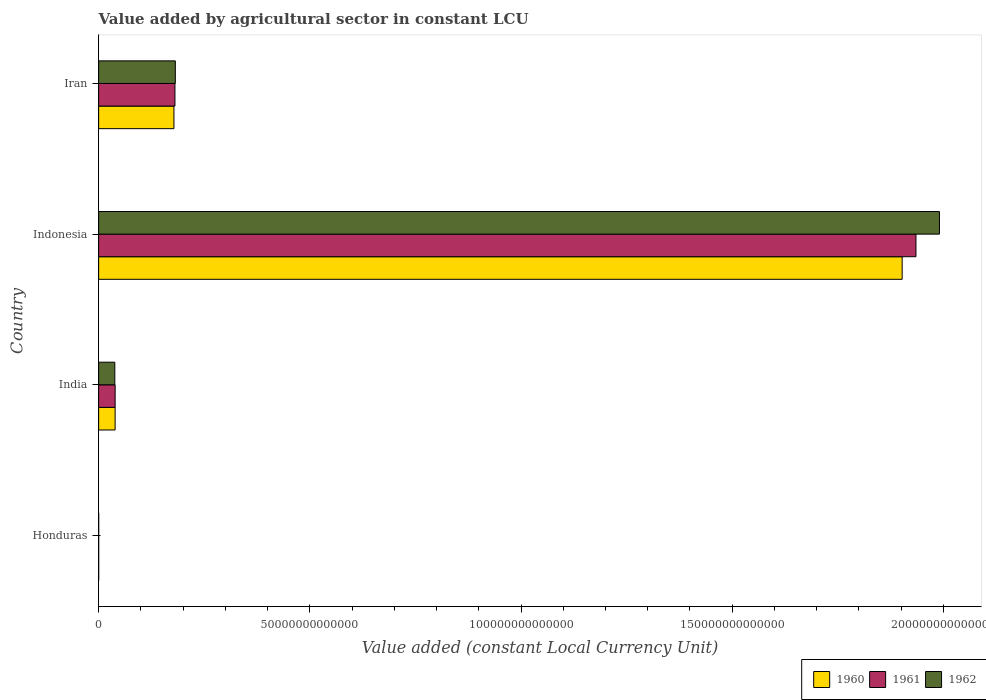How many different coloured bars are there?
Provide a short and direct response. 3. In how many cases, is the number of bars for a given country not equal to the number of legend labels?
Offer a terse response. 0. What is the value added by agricultural sector in 1962 in Indonesia?
Make the answer very short. 1.99e+14. Across all countries, what is the maximum value added by agricultural sector in 1960?
Your response must be concise. 1.90e+14. Across all countries, what is the minimum value added by agricultural sector in 1961?
Offer a very short reply. 4.73e+09. In which country was the value added by agricultural sector in 1960 minimum?
Your response must be concise. Honduras. What is the total value added by agricultural sector in 1961 in the graph?
Keep it short and to the point. 2.15e+14. What is the difference between the value added by agricultural sector in 1961 in India and that in Indonesia?
Ensure brevity in your answer.  -1.90e+14. What is the difference between the value added by agricultural sector in 1962 in India and the value added by agricultural sector in 1961 in Indonesia?
Offer a terse response. -1.90e+14. What is the average value added by agricultural sector in 1960 per country?
Your answer should be compact. 5.30e+13. What is the difference between the value added by agricultural sector in 1960 and value added by agricultural sector in 1961 in Iran?
Your answer should be very brief. -2.42e+11. What is the ratio of the value added by agricultural sector in 1961 in Honduras to that in India?
Provide a succinct answer. 0. What is the difference between the highest and the second highest value added by agricultural sector in 1962?
Your response must be concise. 1.81e+14. What is the difference between the highest and the lowest value added by agricultural sector in 1962?
Offer a terse response. 1.99e+14. Is the sum of the value added by agricultural sector in 1962 in Honduras and Indonesia greater than the maximum value added by agricultural sector in 1961 across all countries?
Offer a terse response. Yes. What does the 1st bar from the bottom in Honduras represents?
Offer a terse response. 1960. How many countries are there in the graph?
Your response must be concise. 4. What is the difference between two consecutive major ticks on the X-axis?
Offer a very short reply. 5.00e+13. Are the values on the major ticks of X-axis written in scientific E-notation?
Your response must be concise. No. Does the graph contain any zero values?
Provide a succinct answer. No. Where does the legend appear in the graph?
Provide a succinct answer. Bottom right. How many legend labels are there?
Your response must be concise. 3. How are the legend labels stacked?
Make the answer very short. Horizontal. What is the title of the graph?
Provide a succinct answer. Value added by agricultural sector in constant LCU. What is the label or title of the X-axis?
Your answer should be compact. Value added (constant Local Currency Unit). What is the Value added (constant Local Currency Unit) in 1960 in Honduras?
Ensure brevity in your answer.  4.44e+09. What is the Value added (constant Local Currency Unit) of 1961 in Honduras?
Provide a short and direct response. 4.73e+09. What is the Value added (constant Local Currency Unit) in 1962 in Honduras?
Provide a short and direct response. 4.96e+09. What is the Value added (constant Local Currency Unit) in 1960 in India?
Offer a very short reply. 3.90e+12. What is the Value added (constant Local Currency Unit) of 1961 in India?
Your answer should be very brief. 3.91e+12. What is the Value added (constant Local Currency Unit) in 1962 in India?
Offer a terse response. 3.83e+12. What is the Value added (constant Local Currency Unit) of 1960 in Indonesia?
Your response must be concise. 1.90e+14. What is the Value added (constant Local Currency Unit) in 1961 in Indonesia?
Give a very brief answer. 1.94e+14. What is the Value added (constant Local Currency Unit) of 1962 in Indonesia?
Provide a short and direct response. 1.99e+14. What is the Value added (constant Local Currency Unit) of 1960 in Iran?
Ensure brevity in your answer.  1.78e+13. What is the Value added (constant Local Currency Unit) in 1961 in Iran?
Ensure brevity in your answer.  1.81e+13. What is the Value added (constant Local Currency Unit) in 1962 in Iran?
Provide a short and direct response. 1.82e+13. Across all countries, what is the maximum Value added (constant Local Currency Unit) in 1960?
Offer a very short reply. 1.90e+14. Across all countries, what is the maximum Value added (constant Local Currency Unit) of 1961?
Give a very brief answer. 1.94e+14. Across all countries, what is the maximum Value added (constant Local Currency Unit) in 1962?
Give a very brief answer. 1.99e+14. Across all countries, what is the minimum Value added (constant Local Currency Unit) in 1960?
Give a very brief answer. 4.44e+09. Across all countries, what is the minimum Value added (constant Local Currency Unit) of 1961?
Your answer should be compact. 4.73e+09. Across all countries, what is the minimum Value added (constant Local Currency Unit) in 1962?
Your response must be concise. 4.96e+09. What is the total Value added (constant Local Currency Unit) in 1960 in the graph?
Provide a succinct answer. 2.12e+14. What is the total Value added (constant Local Currency Unit) of 1961 in the graph?
Keep it short and to the point. 2.15e+14. What is the total Value added (constant Local Currency Unit) in 1962 in the graph?
Your answer should be very brief. 2.21e+14. What is the difference between the Value added (constant Local Currency Unit) of 1960 in Honduras and that in India?
Your answer should be compact. -3.90e+12. What is the difference between the Value added (constant Local Currency Unit) of 1961 in Honduras and that in India?
Offer a very short reply. -3.90e+12. What is the difference between the Value added (constant Local Currency Unit) of 1962 in Honduras and that in India?
Provide a succinct answer. -3.82e+12. What is the difference between the Value added (constant Local Currency Unit) of 1960 in Honduras and that in Indonesia?
Your answer should be very brief. -1.90e+14. What is the difference between the Value added (constant Local Currency Unit) in 1961 in Honduras and that in Indonesia?
Make the answer very short. -1.94e+14. What is the difference between the Value added (constant Local Currency Unit) in 1962 in Honduras and that in Indonesia?
Ensure brevity in your answer.  -1.99e+14. What is the difference between the Value added (constant Local Currency Unit) of 1960 in Honduras and that in Iran?
Your answer should be compact. -1.78e+13. What is the difference between the Value added (constant Local Currency Unit) in 1961 in Honduras and that in Iran?
Your answer should be compact. -1.81e+13. What is the difference between the Value added (constant Local Currency Unit) in 1962 in Honduras and that in Iran?
Ensure brevity in your answer.  -1.82e+13. What is the difference between the Value added (constant Local Currency Unit) in 1960 in India and that in Indonesia?
Keep it short and to the point. -1.86e+14. What is the difference between the Value added (constant Local Currency Unit) in 1961 in India and that in Indonesia?
Keep it short and to the point. -1.90e+14. What is the difference between the Value added (constant Local Currency Unit) in 1962 in India and that in Indonesia?
Provide a succinct answer. -1.95e+14. What is the difference between the Value added (constant Local Currency Unit) in 1960 in India and that in Iran?
Your response must be concise. -1.39e+13. What is the difference between the Value added (constant Local Currency Unit) of 1961 in India and that in Iran?
Offer a terse response. -1.42e+13. What is the difference between the Value added (constant Local Currency Unit) in 1962 in India and that in Iran?
Your response must be concise. -1.43e+13. What is the difference between the Value added (constant Local Currency Unit) in 1960 in Indonesia and that in Iran?
Keep it short and to the point. 1.72e+14. What is the difference between the Value added (constant Local Currency Unit) in 1961 in Indonesia and that in Iran?
Your answer should be compact. 1.75e+14. What is the difference between the Value added (constant Local Currency Unit) of 1962 in Indonesia and that in Iran?
Offer a terse response. 1.81e+14. What is the difference between the Value added (constant Local Currency Unit) in 1960 in Honduras and the Value added (constant Local Currency Unit) in 1961 in India?
Your answer should be very brief. -3.90e+12. What is the difference between the Value added (constant Local Currency Unit) of 1960 in Honduras and the Value added (constant Local Currency Unit) of 1962 in India?
Provide a succinct answer. -3.83e+12. What is the difference between the Value added (constant Local Currency Unit) in 1961 in Honduras and the Value added (constant Local Currency Unit) in 1962 in India?
Make the answer very short. -3.83e+12. What is the difference between the Value added (constant Local Currency Unit) in 1960 in Honduras and the Value added (constant Local Currency Unit) in 1961 in Indonesia?
Your answer should be compact. -1.94e+14. What is the difference between the Value added (constant Local Currency Unit) of 1960 in Honduras and the Value added (constant Local Currency Unit) of 1962 in Indonesia?
Offer a very short reply. -1.99e+14. What is the difference between the Value added (constant Local Currency Unit) of 1961 in Honduras and the Value added (constant Local Currency Unit) of 1962 in Indonesia?
Ensure brevity in your answer.  -1.99e+14. What is the difference between the Value added (constant Local Currency Unit) in 1960 in Honduras and the Value added (constant Local Currency Unit) in 1961 in Iran?
Provide a short and direct response. -1.81e+13. What is the difference between the Value added (constant Local Currency Unit) in 1960 in Honduras and the Value added (constant Local Currency Unit) in 1962 in Iran?
Your answer should be compact. -1.82e+13. What is the difference between the Value added (constant Local Currency Unit) in 1961 in Honduras and the Value added (constant Local Currency Unit) in 1962 in Iran?
Provide a short and direct response. -1.82e+13. What is the difference between the Value added (constant Local Currency Unit) in 1960 in India and the Value added (constant Local Currency Unit) in 1961 in Indonesia?
Offer a very short reply. -1.90e+14. What is the difference between the Value added (constant Local Currency Unit) of 1960 in India and the Value added (constant Local Currency Unit) of 1962 in Indonesia?
Make the answer very short. -1.95e+14. What is the difference between the Value added (constant Local Currency Unit) of 1961 in India and the Value added (constant Local Currency Unit) of 1962 in Indonesia?
Offer a terse response. -1.95e+14. What is the difference between the Value added (constant Local Currency Unit) of 1960 in India and the Value added (constant Local Currency Unit) of 1961 in Iran?
Offer a very short reply. -1.42e+13. What is the difference between the Value added (constant Local Currency Unit) in 1960 in India and the Value added (constant Local Currency Unit) in 1962 in Iran?
Provide a succinct answer. -1.43e+13. What is the difference between the Value added (constant Local Currency Unit) in 1961 in India and the Value added (constant Local Currency Unit) in 1962 in Iran?
Make the answer very short. -1.43e+13. What is the difference between the Value added (constant Local Currency Unit) of 1960 in Indonesia and the Value added (constant Local Currency Unit) of 1961 in Iran?
Ensure brevity in your answer.  1.72e+14. What is the difference between the Value added (constant Local Currency Unit) in 1960 in Indonesia and the Value added (constant Local Currency Unit) in 1962 in Iran?
Provide a short and direct response. 1.72e+14. What is the difference between the Value added (constant Local Currency Unit) of 1961 in Indonesia and the Value added (constant Local Currency Unit) of 1962 in Iran?
Provide a succinct answer. 1.75e+14. What is the average Value added (constant Local Currency Unit) in 1960 per country?
Your answer should be compact. 5.30e+13. What is the average Value added (constant Local Currency Unit) in 1961 per country?
Your response must be concise. 5.39e+13. What is the average Value added (constant Local Currency Unit) in 1962 per country?
Your response must be concise. 5.53e+13. What is the difference between the Value added (constant Local Currency Unit) in 1960 and Value added (constant Local Currency Unit) in 1961 in Honduras?
Ensure brevity in your answer.  -2.90e+08. What is the difference between the Value added (constant Local Currency Unit) in 1960 and Value added (constant Local Currency Unit) in 1962 in Honduras?
Offer a very short reply. -5.15e+08. What is the difference between the Value added (constant Local Currency Unit) of 1961 and Value added (constant Local Currency Unit) of 1962 in Honduras?
Your answer should be compact. -2.25e+08. What is the difference between the Value added (constant Local Currency Unit) of 1960 and Value added (constant Local Currency Unit) of 1961 in India?
Ensure brevity in your answer.  -3.29e+09. What is the difference between the Value added (constant Local Currency Unit) of 1960 and Value added (constant Local Currency Unit) of 1962 in India?
Keep it short and to the point. 7.44e+1. What is the difference between the Value added (constant Local Currency Unit) of 1961 and Value added (constant Local Currency Unit) of 1962 in India?
Ensure brevity in your answer.  7.77e+1. What is the difference between the Value added (constant Local Currency Unit) in 1960 and Value added (constant Local Currency Unit) in 1961 in Indonesia?
Your answer should be compact. -3.27e+12. What is the difference between the Value added (constant Local Currency Unit) in 1960 and Value added (constant Local Currency Unit) in 1962 in Indonesia?
Offer a terse response. -8.83e+12. What is the difference between the Value added (constant Local Currency Unit) of 1961 and Value added (constant Local Currency Unit) of 1962 in Indonesia?
Your answer should be very brief. -5.56e+12. What is the difference between the Value added (constant Local Currency Unit) of 1960 and Value added (constant Local Currency Unit) of 1961 in Iran?
Provide a succinct answer. -2.42e+11. What is the difference between the Value added (constant Local Currency Unit) in 1960 and Value added (constant Local Currency Unit) in 1962 in Iran?
Give a very brief answer. -3.32e+11. What is the difference between the Value added (constant Local Currency Unit) in 1961 and Value added (constant Local Currency Unit) in 1962 in Iran?
Your answer should be compact. -8.95e+1. What is the ratio of the Value added (constant Local Currency Unit) in 1960 in Honduras to that in India?
Offer a terse response. 0. What is the ratio of the Value added (constant Local Currency Unit) in 1961 in Honduras to that in India?
Your answer should be very brief. 0. What is the ratio of the Value added (constant Local Currency Unit) in 1962 in Honduras to that in India?
Offer a very short reply. 0. What is the ratio of the Value added (constant Local Currency Unit) in 1961 in Honduras to that in Indonesia?
Keep it short and to the point. 0. What is the ratio of the Value added (constant Local Currency Unit) in 1961 in Honduras to that in Iran?
Keep it short and to the point. 0. What is the ratio of the Value added (constant Local Currency Unit) in 1962 in Honduras to that in Iran?
Your answer should be compact. 0. What is the ratio of the Value added (constant Local Currency Unit) in 1960 in India to that in Indonesia?
Make the answer very short. 0.02. What is the ratio of the Value added (constant Local Currency Unit) in 1961 in India to that in Indonesia?
Make the answer very short. 0.02. What is the ratio of the Value added (constant Local Currency Unit) of 1962 in India to that in Indonesia?
Ensure brevity in your answer.  0.02. What is the ratio of the Value added (constant Local Currency Unit) in 1960 in India to that in Iran?
Your response must be concise. 0.22. What is the ratio of the Value added (constant Local Currency Unit) in 1961 in India to that in Iran?
Offer a terse response. 0.22. What is the ratio of the Value added (constant Local Currency Unit) of 1962 in India to that in Iran?
Give a very brief answer. 0.21. What is the ratio of the Value added (constant Local Currency Unit) in 1960 in Indonesia to that in Iran?
Provide a succinct answer. 10.67. What is the ratio of the Value added (constant Local Currency Unit) of 1961 in Indonesia to that in Iran?
Your answer should be very brief. 10.71. What is the ratio of the Value added (constant Local Currency Unit) in 1962 in Indonesia to that in Iran?
Provide a short and direct response. 10.96. What is the difference between the highest and the second highest Value added (constant Local Currency Unit) of 1960?
Provide a succinct answer. 1.72e+14. What is the difference between the highest and the second highest Value added (constant Local Currency Unit) in 1961?
Make the answer very short. 1.75e+14. What is the difference between the highest and the second highest Value added (constant Local Currency Unit) in 1962?
Provide a short and direct response. 1.81e+14. What is the difference between the highest and the lowest Value added (constant Local Currency Unit) of 1960?
Your answer should be very brief. 1.90e+14. What is the difference between the highest and the lowest Value added (constant Local Currency Unit) in 1961?
Your response must be concise. 1.94e+14. What is the difference between the highest and the lowest Value added (constant Local Currency Unit) of 1962?
Offer a terse response. 1.99e+14. 